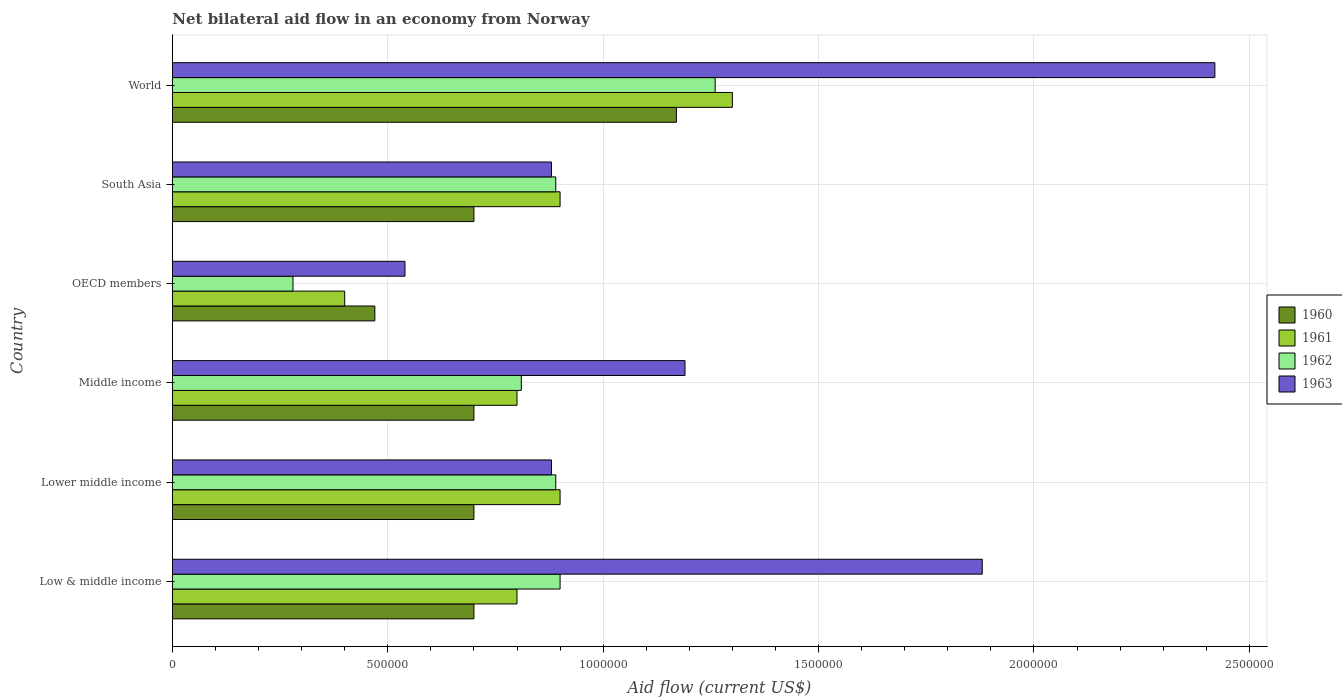Are the number of bars per tick equal to the number of legend labels?
Offer a very short reply. Yes. Are the number of bars on each tick of the Y-axis equal?
Your answer should be compact. Yes. How many bars are there on the 4th tick from the top?
Your response must be concise. 4. How many bars are there on the 3rd tick from the bottom?
Your answer should be compact. 4. What is the label of the 6th group of bars from the top?
Provide a short and direct response. Low & middle income. What is the net bilateral aid flow in 1963 in Middle income?
Provide a short and direct response. 1.19e+06. Across all countries, what is the maximum net bilateral aid flow in 1961?
Make the answer very short. 1.30e+06. Across all countries, what is the minimum net bilateral aid flow in 1963?
Your answer should be very brief. 5.40e+05. In which country was the net bilateral aid flow in 1962 maximum?
Your response must be concise. World. In which country was the net bilateral aid flow in 1963 minimum?
Provide a succinct answer. OECD members. What is the total net bilateral aid flow in 1962 in the graph?
Provide a short and direct response. 5.03e+06. What is the difference between the net bilateral aid flow in 1960 in Middle income and that in World?
Provide a short and direct response. -4.70e+05. What is the average net bilateral aid flow in 1962 per country?
Offer a terse response. 8.38e+05. In how many countries, is the net bilateral aid flow in 1963 greater than 300000 US$?
Give a very brief answer. 6. What is the ratio of the net bilateral aid flow in 1960 in Lower middle income to that in South Asia?
Provide a short and direct response. 1. What is the difference between the highest and the second highest net bilateral aid flow in 1963?
Your answer should be very brief. 5.40e+05. In how many countries, is the net bilateral aid flow in 1962 greater than the average net bilateral aid flow in 1962 taken over all countries?
Provide a succinct answer. 4. Is it the case that in every country, the sum of the net bilateral aid flow in 1962 and net bilateral aid flow in 1961 is greater than the sum of net bilateral aid flow in 1963 and net bilateral aid flow in 1960?
Make the answer very short. No. What does the 4th bar from the bottom in Low & middle income represents?
Your answer should be very brief. 1963. How many bars are there?
Keep it short and to the point. 24. Are all the bars in the graph horizontal?
Your answer should be compact. Yes. How many countries are there in the graph?
Offer a very short reply. 6. What is the difference between two consecutive major ticks on the X-axis?
Offer a terse response. 5.00e+05. Are the values on the major ticks of X-axis written in scientific E-notation?
Your response must be concise. No. Where does the legend appear in the graph?
Ensure brevity in your answer.  Center right. How are the legend labels stacked?
Make the answer very short. Vertical. What is the title of the graph?
Provide a succinct answer. Net bilateral aid flow in an economy from Norway. Does "2010" appear as one of the legend labels in the graph?
Make the answer very short. No. What is the label or title of the Y-axis?
Make the answer very short. Country. What is the Aid flow (current US$) of 1960 in Low & middle income?
Your answer should be very brief. 7.00e+05. What is the Aid flow (current US$) of 1961 in Low & middle income?
Give a very brief answer. 8.00e+05. What is the Aid flow (current US$) in 1962 in Low & middle income?
Your response must be concise. 9.00e+05. What is the Aid flow (current US$) of 1963 in Low & middle income?
Provide a short and direct response. 1.88e+06. What is the Aid flow (current US$) of 1962 in Lower middle income?
Your response must be concise. 8.90e+05. What is the Aid flow (current US$) in 1963 in Lower middle income?
Give a very brief answer. 8.80e+05. What is the Aid flow (current US$) of 1962 in Middle income?
Offer a very short reply. 8.10e+05. What is the Aid flow (current US$) of 1963 in Middle income?
Provide a short and direct response. 1.19e+06. What is the Aid flow (current US$) in 1961 in OECD members?
Provide a short and direct response. 4.00e+05. What is the Aid flow (current US$) of 1962 in OECD members?
Make the answer very short. 2.80e+05. What is the Aid flow (current US$) of 1963 in OECD members?
Your answer should be compact. 5.40e+05. What is the Aid flow (current US$) in 1960 in South Asia?
Ensure brevity in your answer.  7.00e+05. What is the Aid flow (current US$) of 1962 in South Asia?
Make the answer very short. 8.90e+05. What is the Aid flow (current US$) in 1963 in South Asia?
Your answer should be compact. 8.80e+05. What is the Aid flow (current US$) in 1960 in World?
Your answer should be very brief. 1.17e+06. What is the Aid flow (current US$) in 1961 in World?
Provide a short and direct response. 1.30e+06. What is the Aid flow (current US$) of 1962 in World?
Offer a very short reply. 1.26e+06. What is the Aid flow (current US$) in 1963 in World?
Offer a very short reply. 2.42e+06. Across all countries, what is the maximum Aid flow (current US$) in 1960?
Make the answer very short. 1.17e+06. Across all countries, what is the maximum Aid flow (current US$) in 1961?
Your answer should be very brief. 1.30e+06. Across all countries, what is the maximum Aid flow (current US$) of 1962?
Provide a succinct answer. 1.26e+06. Across all countries, what is the maximum Aid flow (current US$) of 1963?
Your answer should be compact. 2.42e+06. Across all countries, what is the minimum Aid flow (current US$) in 1960?
Provide a succinct answer. 4.70e+05. Across all countries, what is the minimum Aid flow (current US$) in 1962?
Provide a succinct answer. 2.80e+05. Across all countries, what is the minimum Aid flow (current US$) in 1963?
Provide a succinct answer. 5.40e+05. What is the total Aid flow (current US$) of 1960 in the graph?
Offer a terse response. 4.44e+06. What is the total Aid flow (current US$) in 1961 in the graph?
Give a very brief answer. 5.10e+06. What is the total Aid flow (current US$) of 1962 in the graph?
Provide a succinct answer. 5.03e+06. What is the total Aid flow (current US$) in 1963 in the graph?
Your answer should be compact. 7.79e+06. What is the difference between the Aid flow (current US$) of 1963 in Low & middle income and that in Lower middle income?
Keep it short and to the point. 1.00e+06. What is the difference between the Aid flow (current US$) in 1961 in Low & middle income and that in Middle income?
Your answer should be compact. 0. What is the difference between the Aid flow (current US$) in 1962 in Low & middle income and that in Middle income?
Your response must be concise. 9.00e+04. What is the difference between the Aid flow (current US$) in 1963 in Low & middle income and that in Middle income?
Provide a short and direct response. 6.90e+05. What is the difference between the Aid flow (current US$) in 1962 in Low & middle income and that in OECD members?
Your response must be concise. 6.20e+05. What is the difference between the Aid flow (current US$) in 1963 in Low & middle income and that in OECD members?
Provide a succinct answer. 1.34e+06. What is the difference between the Aid flow (current US$) of 1961 in Low & middle income and that in South Asia?
Ensure brevity in your answer.  -1.00e+05. What is the difference between the Aid flow (current US$) of 1962 in Low & middle income and that in South Asia?
Provide a succinct answer. 10000. What is the difference between the Aid flow (current US$) of 1963 in Low & middle income and that in South Asia?
Ensure brevity in your answer.  1.00e+06. What is the difference between the Aid flow (current US$) of 1960 in Low & middle income and that in World?
Provide a succinct answer. -4.70e+05. What is the difference between the Aid flow (current US$) of 1961 in Low & middle income and that in World?
Keep it short and to the point. -5.00e+05. What is the difference between the Aid flow (current US$) of 1962 in Low & middle income and that in World?
Make the answer very short. -3.60e+05. What is the difference between the Aid flow (current US$) in 1963 in Low & middle income and that in World?
Your answer should be compact. -5.40e+05. What is the difference between the Aid flow (current US$) of 1963 in Lower middle income and that in Middle income?
Offer a terse response. -3.10e+05. What is the difference between the Aid flow (current US$) in 1963 in Lower middle income and that in South Asia?
Offer a terse response. 0. What is the difference between the Aid flow (current US$) in 1960 in Lower middle income and that in World?
Keep it short and to the point. -4.70e+05. What is the difference between the Aid flow (current US$) in 1961 in Lower middle income and that in World?
Give a very brief answer. -4.00e+05. What is the difference between the Aid flow (current US$) of 1962 in Lower middle income and that in World?
Ensure brevity in your answer.  -3.70e+05. What is the difference between the Aid flow (current US$) of 1963 in Lower middle income and that in World?
Your answer should be very brief. -1.54e+06. What is the difference between the Aid flow (current US$) in 1962 in Middle income and that in OECD members?
Provide a succinct answer. 5.30e+05. What is the difference between the Aid flow (current US$) in 1963 in Middle income and that in OECD members?
Your answer should be very brief. 6.50e+05. What is the difference between the Aid flow (current US$) of 1960 in Middle income and that in South Asia?
Make the answer very short. 0. What is the difference between the Aid flow (current US$) in 1961 in Middle income and that in South Asia?
Offer a very short reply. -1.00e+05. What is the difference between the Aid flow (current US$) in 1960 in Middle income and that in World?
Your answer should be compact. -4.70e+05. What is the difference between the Aid flow (current US$) in 1961 in Middle income and that in World?
Your response must be concise. -5.00e+05. What is the difference between the Aid flow (current US$) in 1962 in Middle income and that in World?
Give a very brief answer. -4.50e+05. What is the difference between the Aid flow (current US$) of 1963 in Middle income and that in World?
Provide a succinct answer. -1.23e+06. What is the difference between the Aid flow (current US$) in 1961 in OECD members and that in South Asia?
Your answer should be very brief. -5.00e+05. What is the difference between the Aid flow (current US$) of 1962 in OECD members and that in South Asia?
Your answer should be very brief. -6.10e+05. What is the difference between the Aid flow (current US$) in 1960 in OECD members and that in World?
Provide a succinct answer. -7.00e+05. What is the difference between the Aid flow (current US$) of 1961 in OECD members and that in World?
Your answer should be very brief. -9.00e+05. What is the difference between the Aid flow (current US$) of 1962 in OECD members and that in World?
Your answer should be very brief. -9.80e+05. What is the difference between the Aid flow (current US$) of 1963 in OECD members and that in World?
Keep it short and to the point. -1.88e+06. What is the difference between the Aid flow (current US$) in 1960 in South Asia and that in World?
Offer a very short reply. -4.70e+05. What is the difference between the Aid flow (current US$) in 1961 in South Asia and that in World?
Provide a succinct answer. -4.00e+05. What is the difference between the Aid flow (current US$) of 1962 in South Asia and that in World?
Your answer should be compact. -3.70e+05. What is the difference between the Aid flow (current US$) of 1963 in South Asia and that in World?
Your answer should be very brief. -1.54e+06. What is the difference between the Aid flow (current US$) of 1960 in Low & middle income and the Aid flow (current US$) of 1961 in Lower middle income?
Your answer should be compact. -2.00e+05. What is the difference between the Aid flow (current US$) of 1960 in Low & middle income and the Aid flow (current US$) of 1962 in Lower middle income?
Keep it short and to the point. -1.90e+05. What is the difference between the Aid flow (current US$) in 1961 in Low & middle income and the Aid flow (current US$) in 1963 in Lower middle income?
Offer a very short reply. -8.00e+04. What is the difference between the Aid flow (current US$) in 1962 in Low & middle income and the Aid flow (current US$) in 1963 in Lower middle income?
Offer a terse response. 2.00e+04. What is the difference between the Aid flow (current US$) of 1960 in Low & middle income and the Aid flow (current US$) of 1961 in Middle income?
Give a very brief answer. -1.00e+05. What is the difference between the Aid flow (current US$) in 1960 in Low & middle income and the Aid flow (current US$) in 1963 in Middle income?
Offer a terse response. -4.90e+05. What is the difference between the Aid flow (current US$) in 1961 in Low & middle income and the Aid flow (current US$) in 1962 in Middle income?
Your answer should be compact. -10000. What is the difference between the Aid flow (current US$) of 1961 in Low & middle income and the Aid flow (current US$) of 1963 in Middle income?
Make the answer very short. -3.90e+05. What is the difference between the Aid flow (current US$) in 1962 in Low & middle income and the Aid flow (current US$) in 1963 in Middle income?
Your answer should be compact. -2.90e+05. What is the difference between the Aid flow (current US$) of 1960 in Low & middle income and the Aid flow (current US$) of 1961 in OECD members?
Provide a succinct answer. 3.00e+05. What is the difference between the Aid flow (current US$) of 1960 in Low & middle income and the Aid flow (current US$) of 1963 in OECD members?
Offer a terse response. 1.60e+05. What is the difference between the Aid flow (current US$) in 1961 in Low & middle income and the Aid flow (current US$) in 1962 in OECD members?
Make the answer very short. 5.20e+05. What is the difference between the Aid flow (current US$) in 1960 in Low & middle income and the Aid flow (current US$) in 1961 in South Asia?
Provide a short and direct response. -2.00e+05. What is the difference between the Aid flow (current US$) of 1960 in Low & middle income and the Aid flow (current US$) of 1963 in South Asia?
Offer a very short reply. -1.80e+05. What is the difference between the Aid flow (current US$) of 1961 in Low & middle income and the Aid flow (current US$) of 1962 in South Asia?
Offer a very short reply. -9.00e+04. What is the difference between the Aid flow (current US$) in 1961 in Low & middle income and the Aid flow (current US$) in 1963 in South Asia?
Provide a succinct answer. -8.00e+04. What is the difference between the Aid flow (current US$) in 1962 in Low & middle income and the Aid flow (current US$) in 1963 in South Asia?
Ensure brevity in your answer.  2.00e+04. What is the difference between the Aid flow (current US$) of 1960 in Low & middle income and the Aid flow (current US$) of 1961 in World?
Ensure brevity in your answer.  -6.00e+05. What is the difference between the Aid flow (current US$) in 1960 in Low & middle income and the Aid flow (current US$) in 1962 in World?
Provide a succinct answer. -5.60e+05. What is the difference between the Aid flow (current US$) of 1960 in Low & middle income and the Aid flow (current US$) of 1963 in World?
Your answer should be compact. -1.72e+06. What is the difference between the Aid flow (current US$) of 1961 in Low & middle income and the Aid flow (current US$) of 1962 in World?
Make the answer very short. -4.60e+05. What is the difference between the Aid flow (current US$) of 1961 in Low & middle income and the Aid flow (current US$) of 1963 in World?
Provide a short and direct response. -1.62e+06. What is the difference between the Aid flow (current US$) in 1962 in Low & middle income and the Aid flow (current US$) in 1963 in World?
Your answer should be compact. -1.52e+06. What is the difference between the Aid flow (current US$) of 1960 in Lower middle income and the Aid flow (current US$) of 1962 in Middle income?
Offer a terse response. -1.10e+05. What is the difference between the Aid flow (current US$) in 1960 in Lower middle income and the Aid flow (current US$) in 1963 in Middle income?
Offer a very short reply. -4.90e+05. What is the difference between the Aid flow (current US$) of 1961 in Lower middle income and the Aid flow (current US$) of 1963 in Middle income?
Offer a very short reply. -2.90e+05. What is the difference between the Aid flow (current US$) in 1960 in Lower middle income and the Aid flow (current US$) in 1961 in OECD members?
Offer a terse response. 3.00e+05. What is the difference between the Aid flow (current US$) in 1960 in Lower middle income and the Aid flow (current US$) in 1963 in OECD members?
Your response must be concise. 1.60e+05. What is the difference between the Aid flow (current US$) of 1961 in Lower middle income and the Aid flow (current US$) of 1962 in OECD members?
Keep it short and to the point. 6.20e+05. What is the difference between the Aid flow (current US$) of 1961 in Lower middle income and the Aid flow (current US$) of 1963 in OECD members?
Your answer should be very brief. 3.60e+05. What is the difference between the Aid flow (current US$) of 1960 in Lower middle income and the Aid flow (current US$) of 1962 in South Asia?
Ensure brevity in your answer.  -1.90e+05. What is the difference between the Aid flow (current US$) of 1962 in Lower middle income and the Aid flow (current US$) of 1963 in South Asia?
Offer a terse response. 10000. What is the difference between the Aid flow (current US$) of 1960 in Lower middle income and the Aid flow (current US$) of 1961 in World?
Your answer should be very brief. -6.00e+05. What is the difference between the Aid flow (current US$) of 1960 in Lower middle income and the Aid flow (current US$) of 1962 in World?
Your answer should be very brief. -5.60e+05. What is the difference between the Aid flow (current US$) of 1960 in Lower middle income and the Aid flow (current US$) of 1963 in World?
Give a very brief answer. -1.72e+06. What is the difference between the Aid flow (current US$) in 1961 in Lower middle income and the Aid flow (current US$) in 1962 in World?
Your answer should be compact. -3.60e+05. What is the difference between the Aid flow (current US$) of 1961 in Lower middle income and the Aid flow (current US$) of 1963 in World?
Offer a very short reply. -1.52e+06. What is the difference between the Aid flow (current US$) of 1962 in Lower middle income and the Aid flow (current US$) of 1963 in World?
Provide a short and direct response. -1.53e+06. What is the difference between the Aid flow (current US$) of 1960 in Middle income and the Aid flow (current US$) of 1961 in OECD members?
Ensure brevity in your answer.  3.00e+05. What is the difference between the Aid flow (current US$) in 1960 in Middle income and the Aid flow (current US$) in 1962 in OECD members?
Your answer should be very brief. 4.20e+05. What is the difference between the Aid flow (current US$) of 1960 in Middle income and the Aid flow (current US$) of 1963 in OECD members?
Make the answer very short. 1.60e+05. What is the difference between the Aid flow (current US$) of 1961 in Middle income and the Aid flow (current US$) of 1962 in OECD members?
Offer a very short reply. 5.20e+05. What is the difference between the Aid flow (current US$) of 1962 in Middle income and the Aid flow (current US$) of 1963 in OECD members?
Your response must be concise. 2.70e+05. What is the difference between the Aid flow (current US$) of 1960 in Middle income and the Aid flow (current US$) of 1961 in South Asia?
Your response must be concise. -2.00e+05. What is the difference between the Aid flow (current US$) in 1960 in Middle income and the Aid flow (current US$) in 1963 in South Asia?
Offer a very short reply. -1.80e+05. What is the difference between the Aid flow (current US$) of 1961 in Middle income and the Aid flow (current US$) of 1962 in South Asia?
Your answer should be very brief. -9.00e+04. What is the difference between the Aid flow (current US$) of 1962 in Middle income and the Aid flow (current US$) of 1963 in South Asia?
Provide a succinct answer. -7.00e+04. What is the difference between the Aid flow (current US$) of 1960 in Middle income and the Aid flow (current US$) of 1961 in World?
Provide a succinct answer. -6.00e+05. What is the difference between the Aid flow (current US$) of 1960 in Middle income and the Aid flow (current US$) of 1962 in World?
Offer a terse response. -5.60e+05. What is the difference between the Aid flow (current US$) in 1960 in Middle income and the Aid flow (current US$) in 1963 in World?
Offer a very short reply. -1.72e+06. What is the difference between the Aid flow (current US$) of 1961 in Middle income and the Aid flow (current US$) of 1962 in World?
Provide a succinct answer. -4.60e+05. What is the difference between the Aid flow (current US$) of 1961 in Middle income and the Aid flow (current US$) of 1963 in World?
Your response must be concise. -1.62e+06. What is the difference between the Aid flow (current US$) of 1962 in Middle income and the Aid flow (current US$) of 1963 in World?
Provide a succinct answer. -1.61e+06. What is the difference between the Aid flow (current US$) of 1960 in OECD members and the Aid flow (current US$) of 1961 in South Asia?
Give a very brief answer. -4.30e+05. What is the difference between the Aid flow (current US$) of 1960 in OECD members and the Aid flow (current US$) of 1962 in South Asia?
Offer a very short reply. -4.20e+05. What is the difference between the Aid flow (current US$) in 1960 in OECD members and the Aid flow (current US$) in 1963 in South Asia?
Your response must be concise. -4.10e+05. What is the difference between the Aid flow (current US$) in 1961 in OECD members and the Aid flow (current US$) in 1962 in South Asia?
Provide a succinct answer. -4.90e+05. What is the difference between the Aid flow (current US$) of 1961 in OECD members and the Aid flow (current US$) of 1963 in South Asia?
Your response must be concise. -4.80e+05. What is the difference between the Aid flow (current US$) in 1962 in OECD members and the Aid flow (current US$) in 1963 in South Asia?
Your answer should be very brief. -6.00e+05. What is the difference between the Aid flow (current US$) in 1960 in OECD members and the Aid flow (current US$) in 1961 in World?
Give a very brief answer. -8.30e+05. What is the difference between the Aid flow (current US$) in 1960 in OECD members and the Aid flow (current US$) in 1962 in World?
Provide a short and direct response. -7.90e+05. What is the difference between the Aid flow (current US$) in 1960 in OECD members and the Aid flow (current US$) in 1963 in World?
Your answer should be compact. -1.95e+06. What is the difference between the Aid flow (current US$) in 1961 in OECD members and the Aid flow (current US$) in 1962 in World?
Provide a short and direct response. -8.60e+05. What is the difference between the Aid flow (current US$) of 1961 in OECD members and the Aid flow (current US$) of 1963 in World?
Provide a succinct answer. -2.02e+06. What is the difference between the Aid flow (current US$) in 1962 in OECD members and the Aid flow (current US$) in 1963 in World?
Make the answer very short. -2.14e+06. What is the difference between the Aid flow (current US$) of 1960 in South Asia and the Aid flow (current US$) of 1961 in World?
Offer a very short reply. -6.00e+05. What is the difference between the Aid flow (current US$) in 1960 in South Asia and the Aid flow (current US$) in 1962 in World?
Provide a succinct answer. -5.60e+05. What is the difference between the Aid flow (current US$) in 1960 in South Asia and the Aid flow (current US$) in 1963 in World?
Give a very brief answer. -1.72e+06. What is the difference between the Aid flow (current US$) in 1961 in South Asia and the Aid flow (current US$) in 1962 in World?
Your response must be concise. -3.60e+05. What is the difference between the Aid flow (current US$) in 1961 in South Asia and the Aid flow (current US$) in 1963 in World?
Offer a very short reply. -1.52e+06. What is the difference between the Aid flow (current US$) in 1962 in South Asia and the Aid flow (current US$) in 1963 in World?
Your answer should be compact. -1.53e+06. What is the average Aid flow (current US$) of 1960 per country?
Give a very brief answer. 7.40e+05. What is the average Aid flow (current US$) of 1961 per country?
Give a very brief answer. 8.50e+05. What is the average Aid flow (current US$) of 1962 per country?
Ensure brevity in your answer.  8.38e+05. What is the average Aid flow (current US$) of 1963 per country?
Offer a very short reply. 1.30e+06. What is the difference between the Aid flow (current US$) of 1960 and Aid flow (current US$) of 1962 in Low & middle income?
Keep it short and to the point. -2.00e+05. What is the difference between the Aid flow (current US$) in 1960 and Aid flow (current US$) in 1963 in Low & middle income?
Provide a short and direct response. -1.18e+06. What is the difference between the Aid flow (current US$) of 1961 and Aid flow (current US$) of 1962 in Low & middle income?
Your response must be concise. -1.00e+05. What is the difference between the Aid flow (current US$) of 1961 and Aid flow (current US$) of 1963 in Low & middle income?
Give a very brief answer. -1.08e+06. What is the difference between the Aid flow (current US$) in 1962 and Aid flow (current US$) in 1963 in Low & middle income?
Provide a succinct answer. -9.80e+05. What is the difference between the Aid flow (current US$) of 1960 and Aid flow (current US$) of 1962 in Lower middle income?
Your answer should be very brief. -1.90e+05. What is the difference between the Aid flow (current US$) in 1960 and Aid flow (current US$) in 1963 in Lower middle income?
Provide a short and direct response. -1.80e+05. What is the difference between the Aid flow (current US$) in 1961 and Aid flow (current US$) in 1962 in Lower middle income?
Your answer should be compact. 10000. What is the difference between the Aid flow (current US$) in 1960 and Aid flow (current US$) in 1962 in Middle income?
Your answer should be compact. -1.10e+05. What is the difference between the Aid flow (current US$) of 1960 and Aid flow (current US$) of 1963 in Middle income?
Make the answer very short. -4.90e+05. What is the difference between the Aid flow (current US$) of 1961 and Aid flow (current US$) of 1963 in Middle income?
Your answer should be compact. -3.90e+05. What is the difference between the Aid flow (current US$) of 1962 and Aid flow (current US$) of 1963 in Middle income?
Give a very brief answer. -3.80e+05. What is the difference between the Aid flow (current US$) of 1960 and Aid flow (current US$) of 1961 in OECD members?
Make the answer very short. 7.00e+04. What is the difference between the Aid flow (current US$) of 1960 and Aid flow (current US$) of 1963 in OECD members?
Provide a short and direct response. -7.00e+04. What is the difference between the Aid flow (current US$) of 1961 and Aid flow (current US$) of 1962 in OECD members?
Give a very brief answer. 1.20e+05. What is the difference between the Aid flow (current US$) of 1961 and Aid flow (current US$) of 1963 in OECD members?
Your response must be concise. -1.40e+05. What is the difference between the Aid flow (current US$) of 1962 and Aid flow (current US$) of 1963 in OECD members?
Make the answer very short. -2.60e+05. What is the difference between the Aid flow (current US$) of 1960 and Aid flow (current US$) of 1962 in South Asia?
Your response must be concise. -1.90e+05. What is the difference between the Aid flow (current US$) of 1960 and Aid flow (current US$) of 1963 in South Asia?
Offer a terse response. -1.80e+05. What is the difference between the Aid flow (current US$) of 1961 and Aid flow (current US$) of 1963 in South Asia?
Provide a succinct answer. 2.00e+04. What is the difference between the Aid flow (current US$) in 1962 and Aid flow (current US$) in 1963 in South Asia?
Ensure brevity in your answer.  10000. What is the difference between the Aid flow (current US$) of 1960 and Aid flow (current US$) of 1963 in World?
Give a very brief answer. -1.25e+06. What is the difference between the Aid flow (current US$) of 1961 and Aid flow (current US$) of 1963 in World?
Provide a succinct answer. -1.12e+06. What is the difference between the Aid flow (current US$) in 1962 and Aid flow (current US$) in 1963 in World?
Provide a short and direct response. -1.16e+06. What is the ratio of the Aid flow (current US$) of 1961 in Low & middle income to that in Lower middle income?
Your answer should be compact. 0.89. What is the ratio of the Aid flow (current US$) of 1962 in Low & middle income to that in Lower middle income?
Offer a terse response. 1.01. What is the ratio of the Aid flow (current US$) of 1963 in Low & middle income to that in Lower middle income?
Provide a succinct answer. 2.14. What is the ratio of the Aid flow (current US$) of 1960 in Low & middle income to that in Middle income?
Your answer should be compact. 1. What is the ratio of the Aid flow (current US$) of 1962 in Low & middle income to that in Middle income?
Your answer should be very brief. 1.11. What is the ratio of the Aid flow (current US$) of 1963 in Low & middle income to that in Middle income?
Give a very brief answer. 1.58. What is the ratio of the Aid flow (current US$) in 1960 in Low & middle income to that in OECD members?
Keep it short and to the point. 1.49. What is the ratio of the Aid flow (current US$) of 1962 in Low & middle income to that in OECD members?
Offer a terse response. 3.21. What is the ratio of the Aid flow (current US$) of 1963 in Low & middle income to that in OECD members?
Your answer should be very brief. 3.48. What is the ratio of the Aid flow (current US$) in 1961 in Low & middle income to that in South Asia?
Provide a succinct answer. 0.89. What is the ratio of the Aid flow (current US$) in 1962 in Low & middle income to that in South Asia?
Provide a succinct answer. 1.01. What is the ratio of the Aid flow (current US$) of 1963 in Low & middle income to that in South Asia?
Keep it short and to the point. 2.14. What is the ratio of the Aid flow (current US$) in 1960 in Low & middle income to that in World?
Offer a very short reply. 0.6. What is the ratio of the Aid flow (current US$) in 1961 in Low & middle income to that in World?
Provide a succinct answer. 0.62. What is the ratio of the Aid flow (current US$) of 1962 in Low & middle income to that in World?
Ensure brevity in your answer.  0.71. What is the ratio of the Aid flow (current US$) in 1963 in Low & middle income to that in World?
Provide a short and direct response. 0.78. What is the ratio of the Aid flow (current US$) of 1960 in Lower middle income to that in Middle income?
Keep it short and to the point. 1. What is the ratio of the Aid flow (current US$) in 1962 in Lower middle income to that in Middle income?
Your response must be concise. 1.1. What is the ratio of the Aid flow (current US$) of 1963 in Lower middle income to that in Middle income?
Keep it short and to the point. 0.74. What is the ratio of the Aid flow (current US$) of 1960 in Lower middle income to that in OECD members?
Your answer should be compact. 1.49. What is the ratio of the Aid flow (current US$) in 1961 in Lower middle income to that in OECD members?
Offer a terse response. 2.25. What is the ratio of the Aid flow (current US$) in 1962 in Lower middle income to that in OECD members?
Give a very brief answer. 3.18. What is the ratio of the Aid flow (current US$) of 1963 in Lower middle income to that in OECD members?
Your response must be concise. 1.63. What is the ratio of the Aid flow (current US$) in 1962 in Lower middle income to that in South Asia?
Give a very brief answer. 1. What is the ratio of the Aid flow (current US$) in 1960 in Lower middle income to that in World?
Keep it short and to the point. 0.6. What is the ratio of the Aid flow (current US$) in 1961 in Lower middle income to that in World?
Provide a succinct answer. 0.69. What is the ratio of the Aid flow (current US$) in 1962 in Lower middle income to that in World?
Offer a terse response. 0.71. What is the ratio of the Aid flow (current US$) in 1963 in Lower middle income to that in World?
Provide a short and direct response. 0.36. What is the ratio of the Aid flow (current US$) of 1960 in Middle income to that in OECD members?
Offer a terse response. 1.49. What is the ratio of the Aid flow (current US$) in 1962 in Middle income to that in OECD members?
Your answer should be compact. 2.89. What is the ratio of the Aid flow (current US$) of 1963 in Middle income to that in OECD members?
Your answer should be very brief. 2.2. What is the ratio of the Aid flow (current US$) in 1960 in Middle income to that in South Asia?
Keep it short and to the point. 1. What is the ratio of the Aid flow (current US$) of 1961 in Middle income to that in South Asia?
Your response must be concise. 0.89. What is the ratio of the Aid flow (current US$) of 1962 in Middle income to that in South Asia?
Ensure brevity in your answer.  0.91. What is the ratio of the Aid flow (current US$) in 1963 in Middle income to that in South Asia?
Offer a very short reply. 1.35. What is the ratio of the Aid flow (current US$) in 1960 in Middle income to that in World?
Your response must be concise. 0.6. What is the ratio of the Aid flow (current US$) of 1961 in Middle income to that in World?
Your response must be concise. 0.62. What is the ratio of the Aid flow (current US$) of 1962 in Middle income to that in World?
Your response must be concise. 0.64. What is the ratio of the Aid flow (current US$) of 1963 in Middle income to that in World?
Offer a terse response. 0.49. What is the ratio of the Aid flow (current US$) of 1960 in OECD members to that in South Asia?
Make the answer very short. 0.67. What is the ratio of the Aid flow (current US$) of 1961 in OECD members to that in South Asia?
Offer a terse response. 0.44. What is the ratio of the Aid flow (current US$) in 1962 in OECD members to that in South Asia?
Your response must be concise. 0.31. What is the ratio of the Aid flow (current US$) in 1963 in OECD members to that in South Asia?
Your answer should be compact. 0.61. What is the ratio of the Aid flow (current US$) in 1960 in OECD members to that in World?
Offer a terse response. 0.4. What is the ratio of the Aid flow (current US$) in 1961 in OECD members to that in World?
Ensure brevity in your answer.  0.31. What is the ratio of the Aid flow (current US$) of 1962 in OECD members to that in World?
Make the answer very short. 0.22. What is the ratio of the Aid flow (current US$) in 1963 in OECD members to that in World?
Ensure brevity in your answer.  0.22. What is the ratio of the Aid flow (current US$) in 1960 in South Asia to that in World?
Provide a short and direct response. 0.6. What is the ratio of the Aid flow (current US$) of 1961 in South Asia to that in World?
Your answer should be very brief. 0.69. What is the ratio of the Aid flow (current US$) of 1962 in South Asia to that in World?
Ensure brevity in your answer.  0.71. What is the ratio of the Aid flow (current US$) of 1963 in South Asia to that in World?
Your answer should be very brief. 0.36. What is the difference between the highest and the second highest Aid flow (current US$) of 1960?
Your answer should be very brief. 4.70e+05. What is the difference between the highest and the second highest Aid flow (current US$) of 1962?
Provide a succinct answer. 3.60e+05. What is the difference between the highest and the second highest Aid flow (current US$) in 1963?
Your response must be concise. 5.40e+05. What is the difference between the highest and the lowest Aid flow (current US$) of 1961?
Make the answer very short. 9.00e+05. What is the difference between the highest and the lowest Aid flow (current US$) in 1962?
Your answer should be compact. 9.80e+05. What is the difference between the highest and the lowest Aid flow (current US$) in 1963?
Provide a short and direct response. 1.88e+06. 